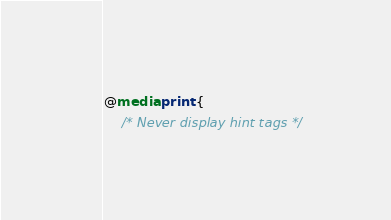Convert code to text. <code><loc_0><loc_0><loc_500><loc_500><_CSS_>@media print {
    /* Never display hint tags */</code> 